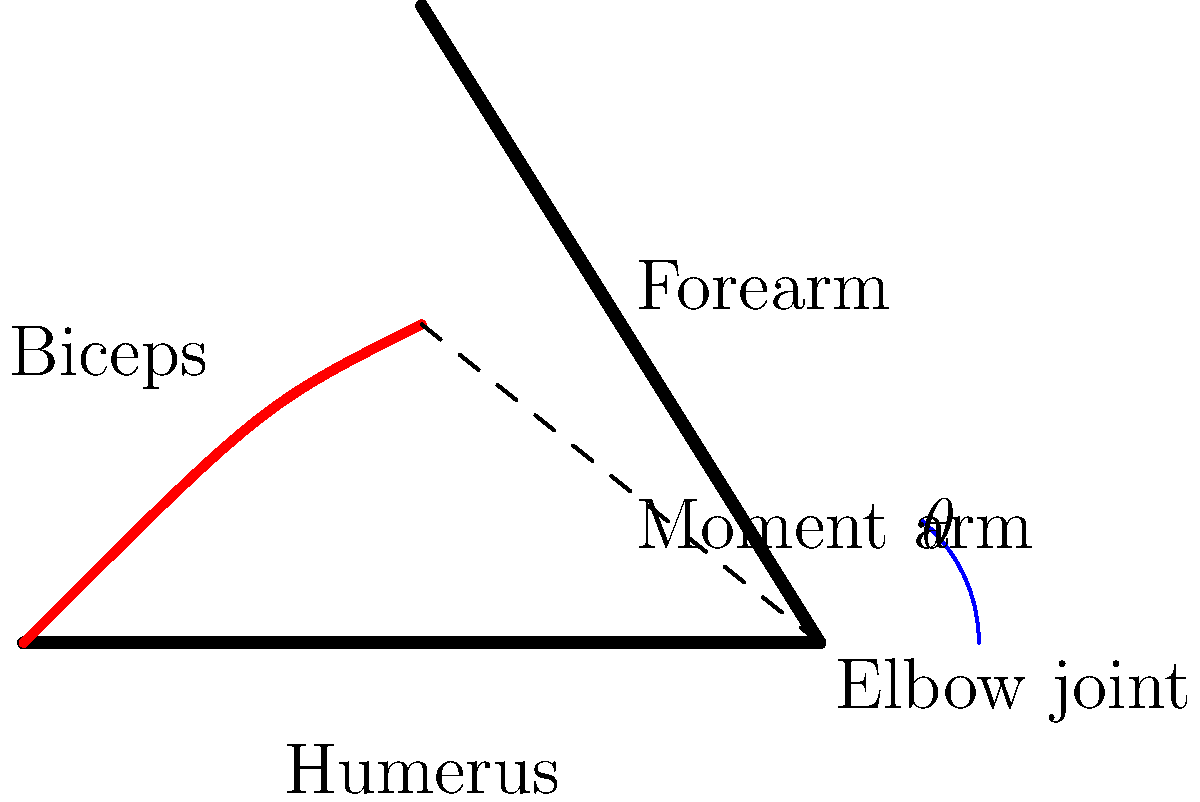In the diagram above, which represents a simplified model of the elbow joint and biceps muscle, how does the moment arm of the biceps change as the elbow flexes (i.e., as $\theta$ increases)? Explain your reasoning. To understand how the moment arm of the biceps changes during elbow flexion, let's follow these steps:

1. Recall that the moment arm is the perpendicular distance from the joint's axis of rotation to the line of action of the muscle force.

2. In this diagram, the moment arm is represented by the dashed line from the elbow joint (point B) perpendicular to the biceps muscle.

3. As the elbow flexes (θ increases):
   a. The forearm (BC) rotates around point B.
   b. The insertion point of the biceps (point D) moves closer to the elbow joint (point B).
   c. The angle between the biceps and the forearm decreases.

4. When the elbow is extended (small θ), the moment arm is relatively small because the biceps is more parallel to the forearm.

5. As flexion increases (larger θ):
   a. The biceps becomes more perpendicular to the forearm.
   b. This increases the perpendicular distance from the joint to the line of action of the muscle.

6. The moment arm reaches its maximum when the biceps is perpendicular to the forearm.

7. If flexion continues beyond this point, the moment arm would start to decrease again.

Therefore, as the elbow flexes from an extended position, the moment arm of the biceps generally increases, reaches a maximum, and then may decrease slightly at extreme flexion angles.
Answer: The moment arm initially increases with elbow flexion, reaches a maximum, then may slightly decrease at extreme flexion. 